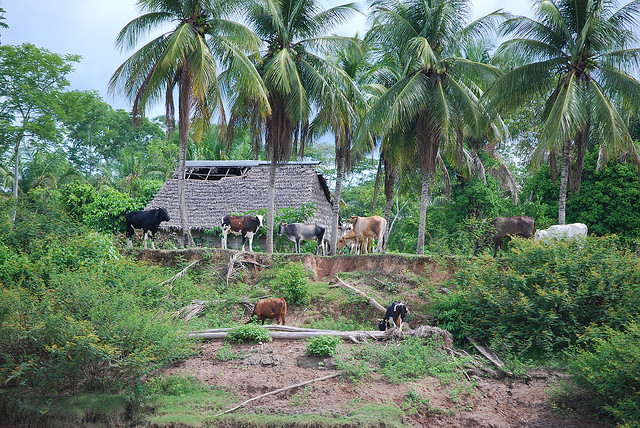<image>What kind of fence is that? I don't know what kind of fence is that. It could be a wooden or natural fence, or there may be no fence at all. What kind of fence is that? I don't know what kind of fence that is. It can be seen as 'dirt', 'wooden', 'none' or 'invisible'. 